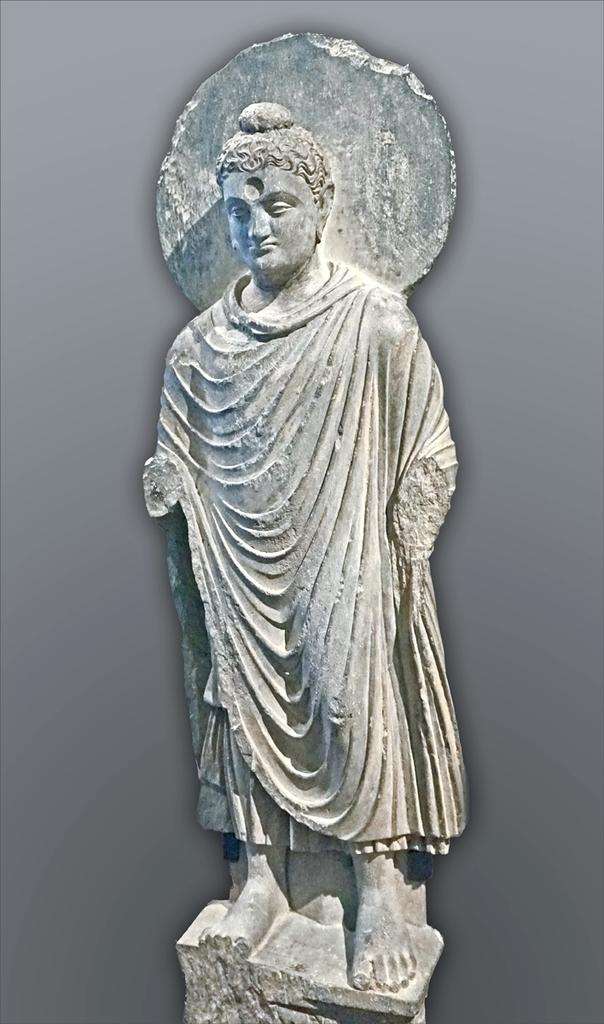What is the color of the background in the image? The background of the picture is in gray color. What can be seen in the foreground of the image? There is a statue in the image. How is the statue positioned in the image? The statue is placed on a pedestal. What type of honey is being collected by the statue in the image? There is no honey or any indication of honey collection in the image; it features a statue placed on a pedestal in a gray background. 